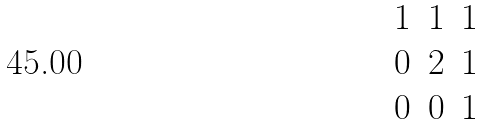<formula> <loc_0><loc_0><loc_500><loc_500>\begin{matrix} 1 & 1 & 1 \\ 0 & 2 & 1 \\ 0 & 0 & 1 \end{matrix}</formula> 